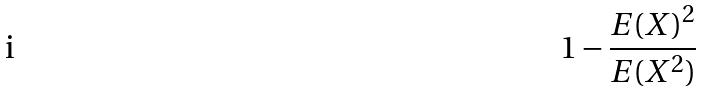Convert formula to latex. <formula><loc_0><loc_0><loc_500><loc_500>1 - \frac { E ( X ) ^ { 2 } } { E ( X ^ { 2 } ) }</formula> 